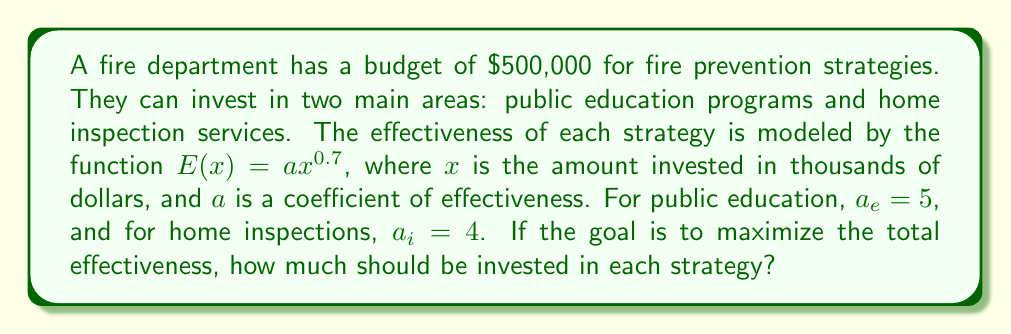Teach me how to tackle this problem. To solve this problem, we'll use the method of Lagrange multipliers, as we're maximizing a function subject to a constraint.

1) Let $x$ be the investment in public education and $y$ be the investment in home inspections (both in thousands of dollars).

2) Our objective function is the total effectiveness:
   $$E(x,y) = 5x^{0.7} + 4y^{0.7}$$

3) Our constraint is the total budget:
   $$x + y = 500$$

4) We form the Lagrangian:
   $$L(x,y,\lambda) = 5x^{0.7} + 4y^{0.7} - \lambda(x + y - 500)$$

5) We take partial derivatives and set them to zero:
   $$\frac{\partial L}{\partial x} = 3.5x^{-0.3} - \lambda = 0$$
   $$\frac{\partial L}{\partial y} = 2.8y^{-0.3} - \lambda = 0$$
   $$\frac{\partial L}{\partial \lambda} = x + y - 500 = 0$$

6) From the first two equations:
   $$3.5x^{-0.3} = 2.8y^{-0.3}$$

7) This simplifies to:
   $$y = (\frac{2.8}{3.5})^{\frac{10}{3}}x \approx 0.6x$$

8) Substituting into the constraint equation:
   $$x + 0.6x = 500$$
   $$1.6x = 500$$
   $$x = 312.5$$

9) Therefore:
   $$y = 500 - 312.5 = 187.5$$
Answer: The optimal allocation is to invest $312,500 in public education programs and $187,500 in home inspection services. 